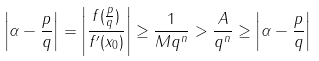<formula> <loc_0><loc_0><loc_500><loc_500>\left | \alpha - { \frac { p } { q } } \right | = \left | { \frac { f ( { \frac { p } { q } } ) } { f ^ { \prime } ( x _ { 0 } ) } } \right | \geq { \frac { 1 } { M q ^ { n } } } > { \frac { A } { q ^ { n } } } \geq \left | \alpha - { \frac { p } { q } } \right |</formula> 